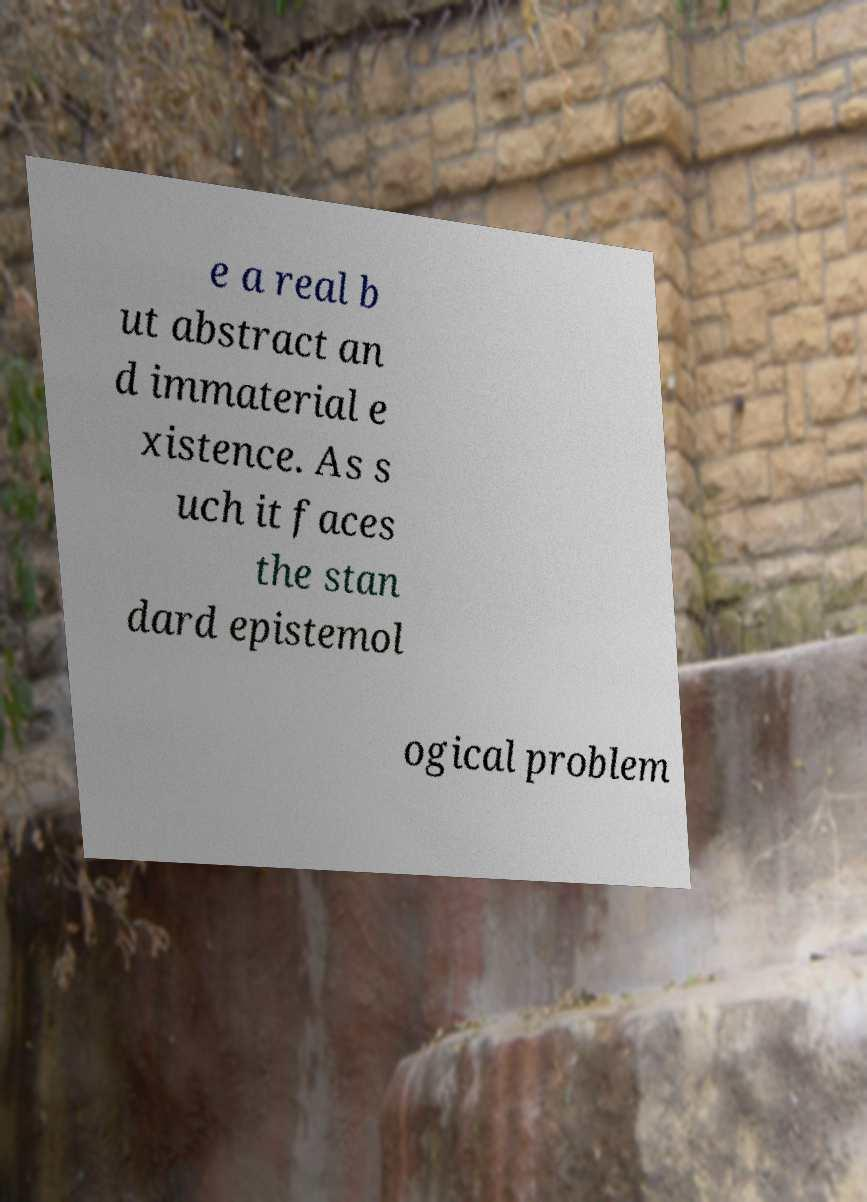Please identify and transcribe the text found in this image. e a real b ut abstract an d immaterial e xistence. As s uch it faces the stan dard epistemol ogical problem 